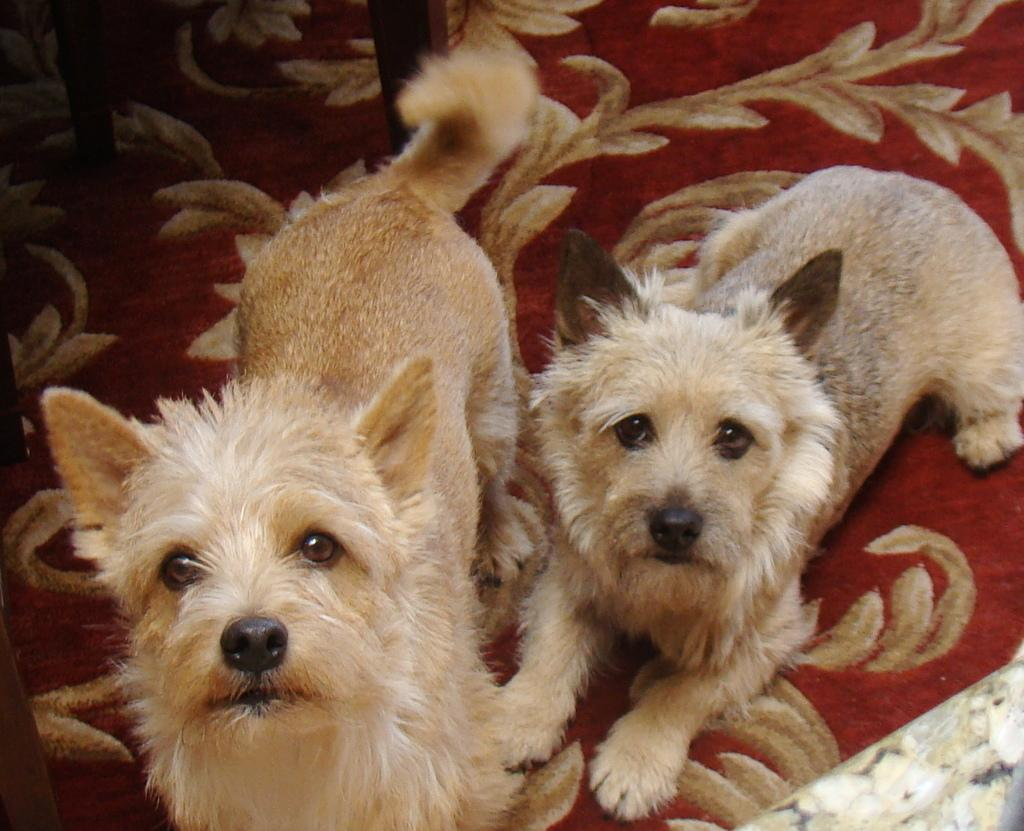How many dogs are in the picture? There are two dogs in the picture. What is the position of the dog on the right side? The dog on the right side is sitting. What is the position of the dog on the left side? The dog on the left side is standing. What color is the object the dog on the left side is standing on? The dog on the left side is standing on a red color object. What type of flowers can be seen growing near the dogs in the image? There are no flowers visible in the image; it only features two dogs in different positions. 